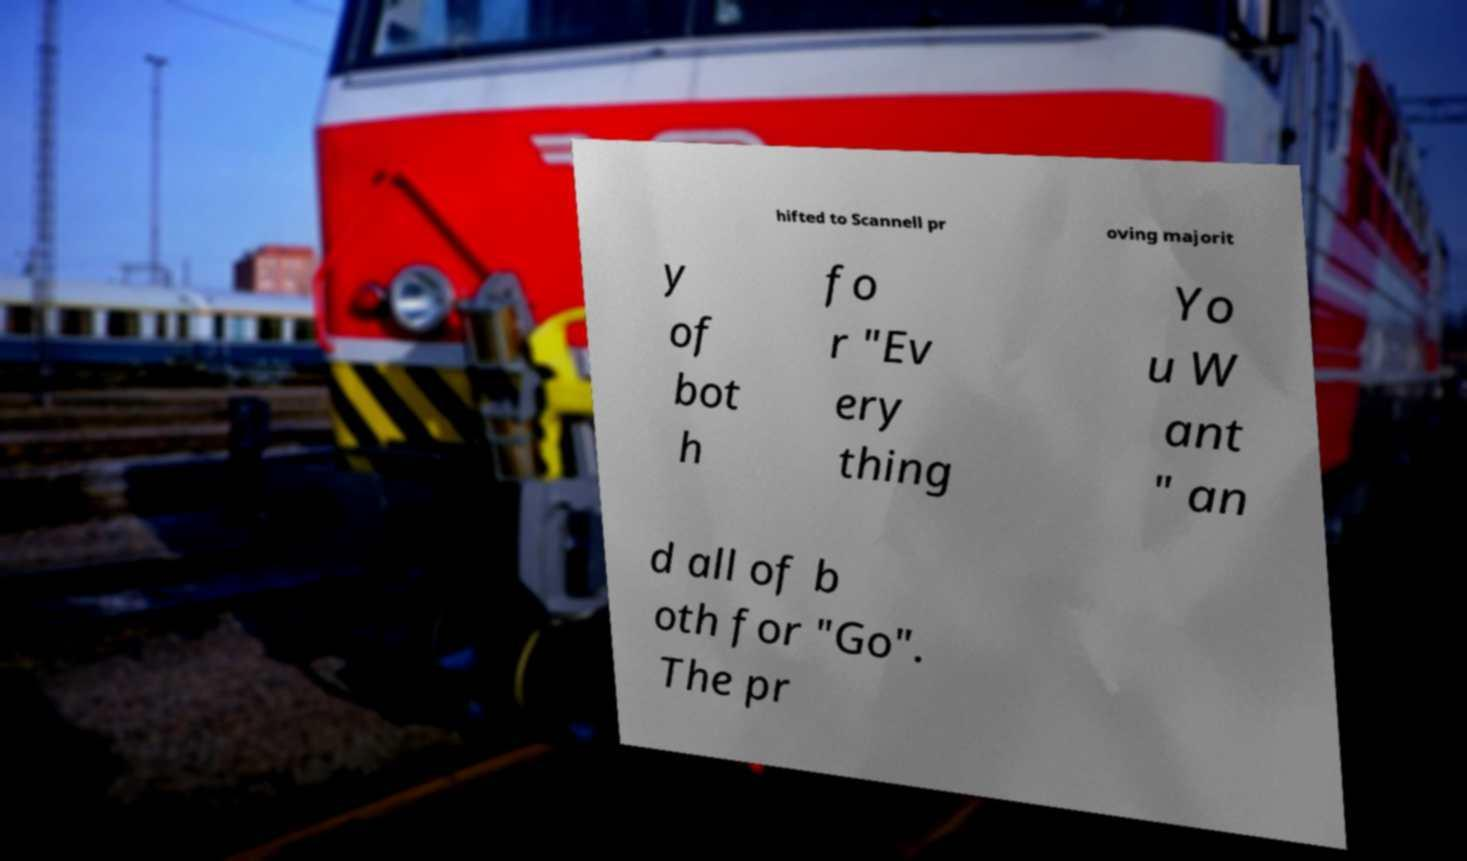Could you extract and type out the text from this image? hifted to Scannell pr oving majorit y of bot h fo r "Ev ery thing Yo u W ant " an d all of b oth for "Go". The pr 